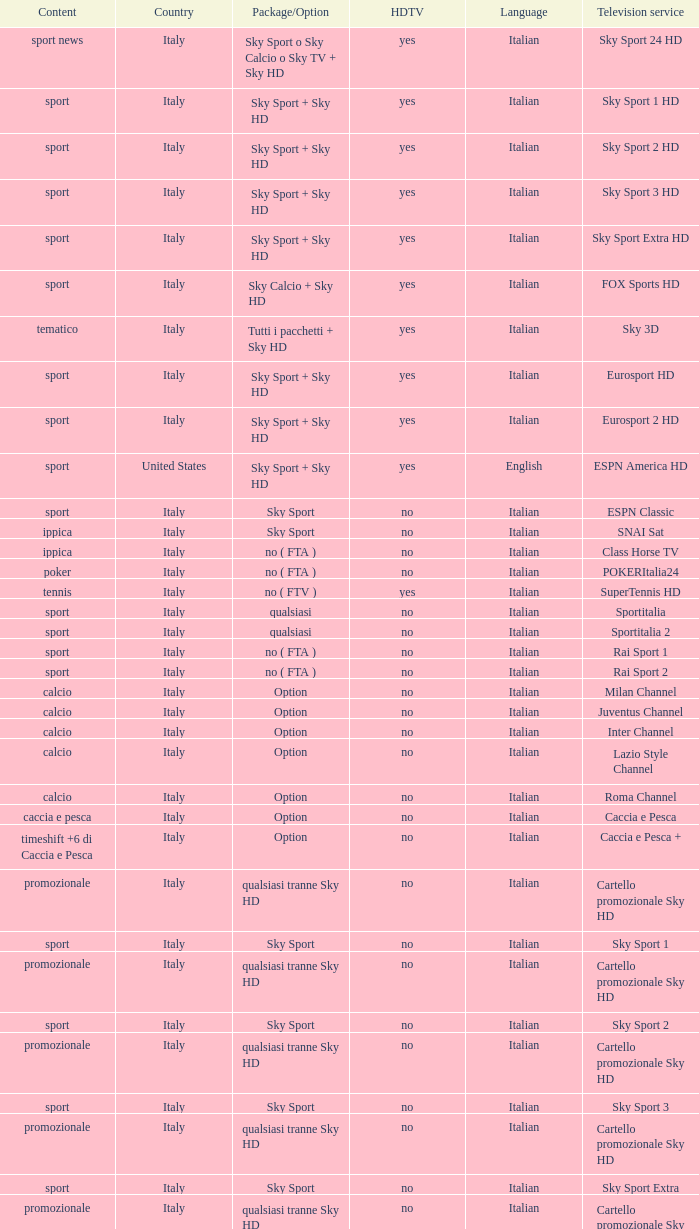What is Country, when Television Service is Eurosport 2? Italy. 